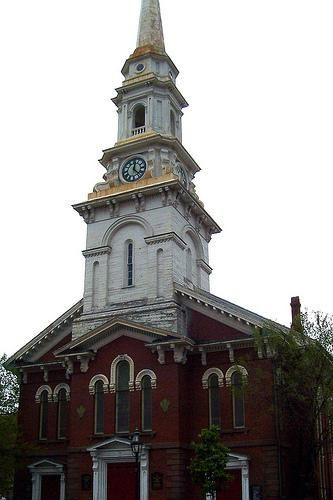Mention the color and the main distinguishing feature of the building in the image. A red brick building with a tall church window and a pointed roof. Describe the appearance and placement of the chimney in relation to the building. A brick chimney with red and black hues, situated towards the top of the building, close to the center. Explain a distinguishing feature of the lamp post present in the image. A black lamp post with a lamp not turned on and a possible wall sconce attached to it. Explain the overall setting of the image with emphasis on the sky. An old, red-brick building set against a sky filled with white clouds, contrasting with the blue sky. Discuss the design and appearance of the clock in the picture. The clock has a blue face with black and white accents, housed in a clock tower. Describe the type and color of tree the image displays. A small green tree with vibrant leaves and a possibly young age. Briefly list the primary objects you observe in the image. Brick building, slim window, long windows, lamp post, clock, chimney, small green tree, clouds, steeple, and red door. Highlight the main components of the scene, focusing on the architectural and natural elements. A red brick church containing a tall arched window, a green tree nearby, and white clouds filling the sky. Elaborate on one of the unique details visible on the brick building. There is a lovely decorative detail with red and gold windows on the brick building. Portray one particular tall window in the image, focusing on its proportions and color. A tall, slim church window in red brick with an elongated and narrow appearance. 